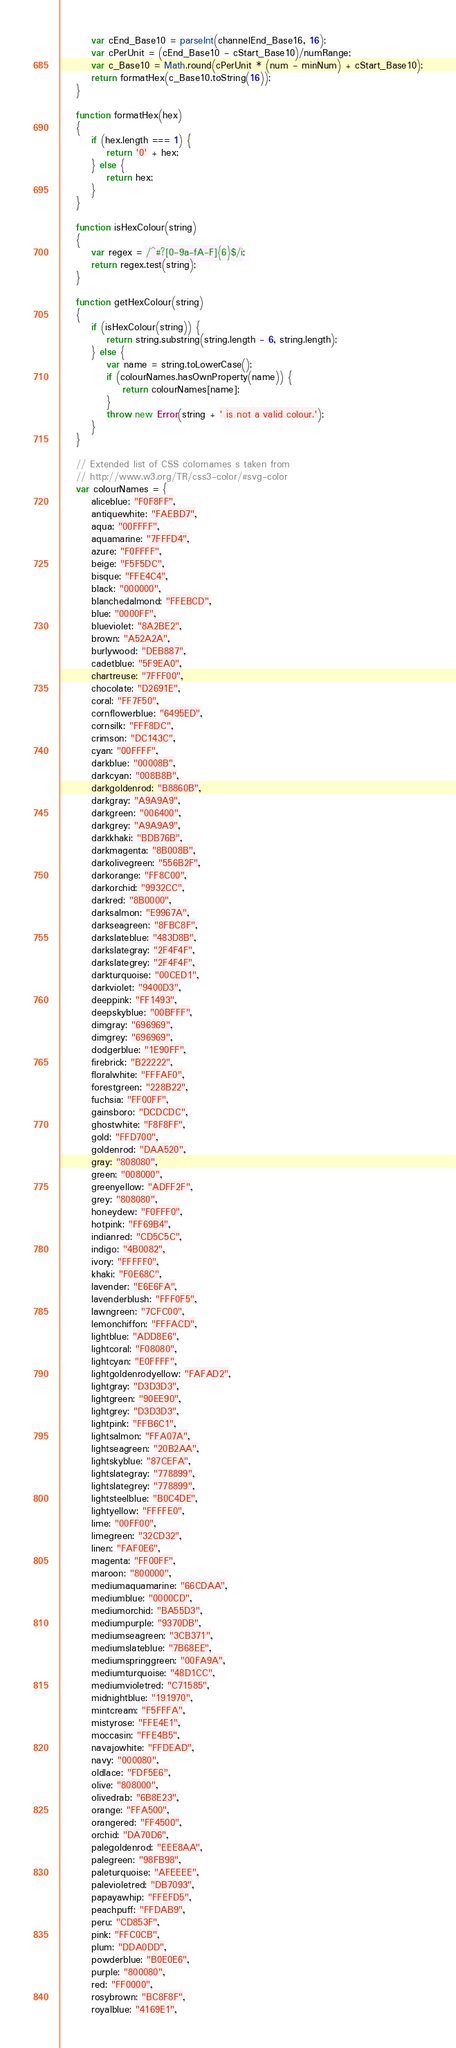<code> <loc_0><loc_0><loc_500><loc_500><_JavaScript_>		var cEnd_Base10 = parseInt(channelEnd_Base16, 16); 
		var cPerUnit = (cEnd_Base10 - cStart_Base10)/numRange;
		var c_Base10 = Math.round(cPerUnit * (num - minNum) + cStart_Base10);
		return formatHex(c_Base10.toString(16));
	}

	function formatHex(hex) 
	{
		if (hex.length === 1) {
			return '0' + hex;
		} else {
			return hex;
		}
	} 
	
	function isHexColour(string)
	{
		var regex = /^#?[0-9a-fA-F]{6}$/i;
		return regex.test(string);
	}

	function getHexColour(string)
	{
		if (isHexColour(string)) {
			return string.substring(string.length - 6, string.length);
		} else {
			var name = string.toLowerCase();
			if (colourNames.hasOwnProperty(name)) {
				return colourNames[name];
			}
			throw new Error(string + ' is not a valid colour.');
		}
	}
	
	// Extended list of CSS colornames s taken from
	// http://www.w3.org/TR/css3-color/#svg-color
	var colourNames = {
		aliceblue: "F0F8FF",
		antiquewhite: "FAEBD7",
		aqua: "00FFFF",
		aquamarine: "7FFFD4",
		azure: "F0FFFF",
		beige: "F5F5DC",
		bisque: "FFE4C4",
		black: "000000",
		blanchedalmond: "FFEBCD",
		blue: "0000FF",
		blueviolet: "8A2BE2",
		brown: "A52A2A",
		burlywood: "DEB887",
		cadetblue: "5F9EA0",
		chartreuse: "7FFF00",
		chocolate: "D2691E",
		coral: "FF7F50",
		cornflowerblue: "6495ED",
		cornsilk: "FFF8DC",
		crimson: "DC143C",
		cyan: "00FFFF",
		darkblue: "00008B",
		darkcyan: "008B8B",
		darkgoldenrod: "B8860B",
		darkgray: "A9A9A9",
		darkgreen: "006400",
		darkgrey: "A9A9A9",
		darkkhaki: "BDB76B",
		darkmagenta: "8B008B",
		darkolivegreen: "556B2F",
		darkorange: "FF8C00",
		darkorchid: "9932CC",
		darkred: "8B0000",
		darksalmon: "E9967A",
		darkseagreen: "8FBC8F",
		darkslateblue: "483D8B",
		darkslategray: "2F4F4F",
		darkslategrey: "2F4F4F",
		darkturquoise: "00CED1",
		darkviolet: "9400D3",
		deeppink: "FF1493",
		deepskyblue: "00BFFF",
		dimgray: "696969",
		dimgrey: "696969",
		dodgerblue: "1E90FF",
		firebrick: "B22222",
		floralwhite: "FFFAF0",
		forestgreen: "228B22",
		fuchsia: "FF00FF",
		gainsboro: "DCDCDC",
		ghostwhite: "F8F8FF",
		gold: "FFD700",
		goldenrod: "DAA520",
		gray: "808080",
		green: "008000",
		greenyellow: "ADFF2F",
		grey: "808080",
		honeydew: "F0FFF0",
		hotpink: "FF69B4",
		indianred: "CD5C5C",
		indigo: "4B0082",
		ivory: "FFFFF0",
		khaki: "F0E68C",
		lavender: "E6E6FA",
		lavenderblush: "FFF0F5",
		lawngreen: "7CFC00",
		lemonchiffon: "FFFACD",
		lightblue: "ADD8E6",
		lightcoral: "F08080",
		lightcyan: "E0FFFF",
		lightgoldenrodyellow: "FAFAD2",
		lightgray: "D3D3D3",
		lightgreen: "90EE90",
		lightgrey: "D3D3D3",
		lightpink: "FFB6C1",
		lightsalmon: "FFA07A",
		lightseagreen: "20B2AA",
		lightskyblue: "87CEFA",
		lightslategray: "778899",
		lightslategrey: "778899",
		lightsteelblue: "B0C4DE",
		lightyellow: "FFFFE0",
		lime: "00FF00",
		limegreen: "32CD32",
		linen: "FAF0E6",
		magenta: "FF00FF",
		maroon: "800000",
		mediumaquamarine: "66CDAA",
		mediumblue: "0000CD",
		mediumorchid: "BA55D3",
		mediumpurple: "9370DB",
		mediumseagreen: "3CB371",
		mediumslateblue: "7B68EE",
		mediumspringgreen: "00FA9A",
		mediumturquoise: "48D1CC",
		mediumvioletred: "C71585",
		midnightblue: "191970",
		mintcream: "F5FFFA",
		mistyrose: "FFE4E1",
		moccasin: "FFE4B5",
		navajowhite: "FFDEAD",
		navy: "000080",
		oldlace: "FDF5E6",
		olive: "808000",
		olivedrab: "6B8E23",
		orange: "FFA500",
		orangered: "FF4500",
		orchid: "DA70D6",
		palegoldenrod: "EEE8AA",
		palegreen: "98FB98",
		paleturquoise: "AFEEEE",
		palevioletred: "DB7093",
		papayawhip: "FFEFD5",
		peachpuff: "FFDAB9",
		peru: "CD853F",
		pink: "FFC0CB",
		plum: "DDA0DD",
		powderblue: "B0E0E6",
		purple: "800080",
		red: "FF0000",
		rosybrown: "BC8F8F",
		royalblue: "4169E1",</code> 